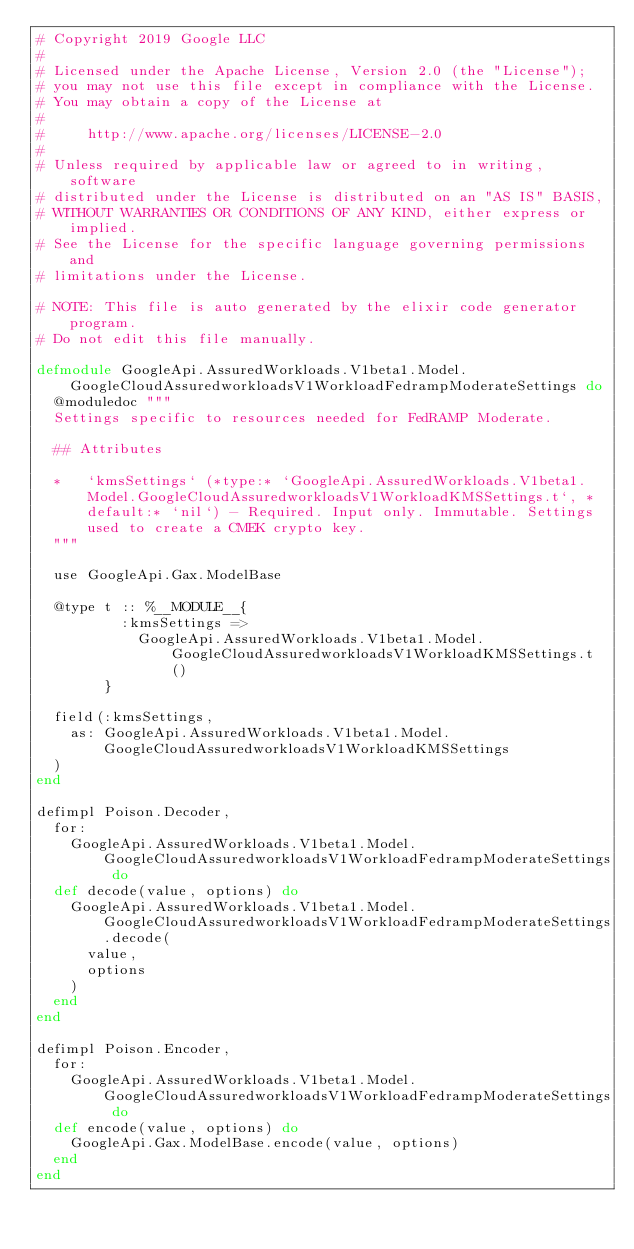Convert code to text. <code><loc_0><loc_0><loc_500><loc_500><_Elixir_># Copyright 2019 Google LLC
#
# Licensed under the Apache License, Version 2.0 (the "License");
# you may not use this file except in compliance with the License.
# You may obtain a copy of the License at
#
#     http://www.apache.org/licenses/LICENSE-2.0
#
# Unless required by applicable law or agreed to in writing, software
# distributed under the License is distributed on an "AS IS" BASIS,
# WITHOUT WARRANTIES OR CONDITIONS OF ANY KIND, either express or implied.
# See the License for the specific language governing permissions and
# limitations under the License.

# NOTE: This file is auto generated by the elixir code generator program.
# Do not edit this file manually.

defmodule GoogleApi.AssuredWorkloads.V1beta1.Model.GoogleCloudAssuredworkloadsV1WorkloadFedrampModerateSettings do
  @moduledoc """
  Settings specific to resources needed for FedRAMP Moderate.

  ## Attributes

  *   `kmsSettings` (*type:* `GoogleApi.AssuredWorkloads.V1beta1.Model.GoogleCloudAssuredworkloadsV1WorkloadKMSSettings.t`, *default:* `nil`) - Required. Input only. Immutable. Settings used to create a CMEK crypto key.
  """

  use GoogleApi.Gax.ModelBase

  @type t :: %__MODULE__{
          :kmsSettings =>
            GoogleApi.AssuredWorkloads.V1beta1.Model.GoogleCloudAssuredworkloadsV1WorkloadKMSSettings.t()
        }

  field(:kmsSettings,
    as: GoogleApi.AssuredWorkloads.V1beta1.Model.GoogleCloudAssuredworkloadsV1WorkloadKMSSettings
  )
end

defimpl Poison.Decoder,
  for:
    GoogleApi.AssuredWorkloads.V1beta1.Model.GoogleCloudAssuredworkloadsV1WorkloadFedrampModerateSettings do
  def decode(value, options) do
    GoogleApi.AssuredWorkloads.V1beta1.Model.GoogleCloudAssuredworkloadsV1WorkloadFedrampModerateSettings.decode(
      value,
      options
    )
  end
end

defimpl Poison.Encoder,
  for:
    GoogleApi.AssuredWorkloads.V1beta1.Model.GoogleCloudAssuredworkloadsV1WorkloadFedrampModerateSettings do
  def encode(value, options) do
    GoogleApi.Gax.ModelBase.encode(value, options)
  end
end
</code> 